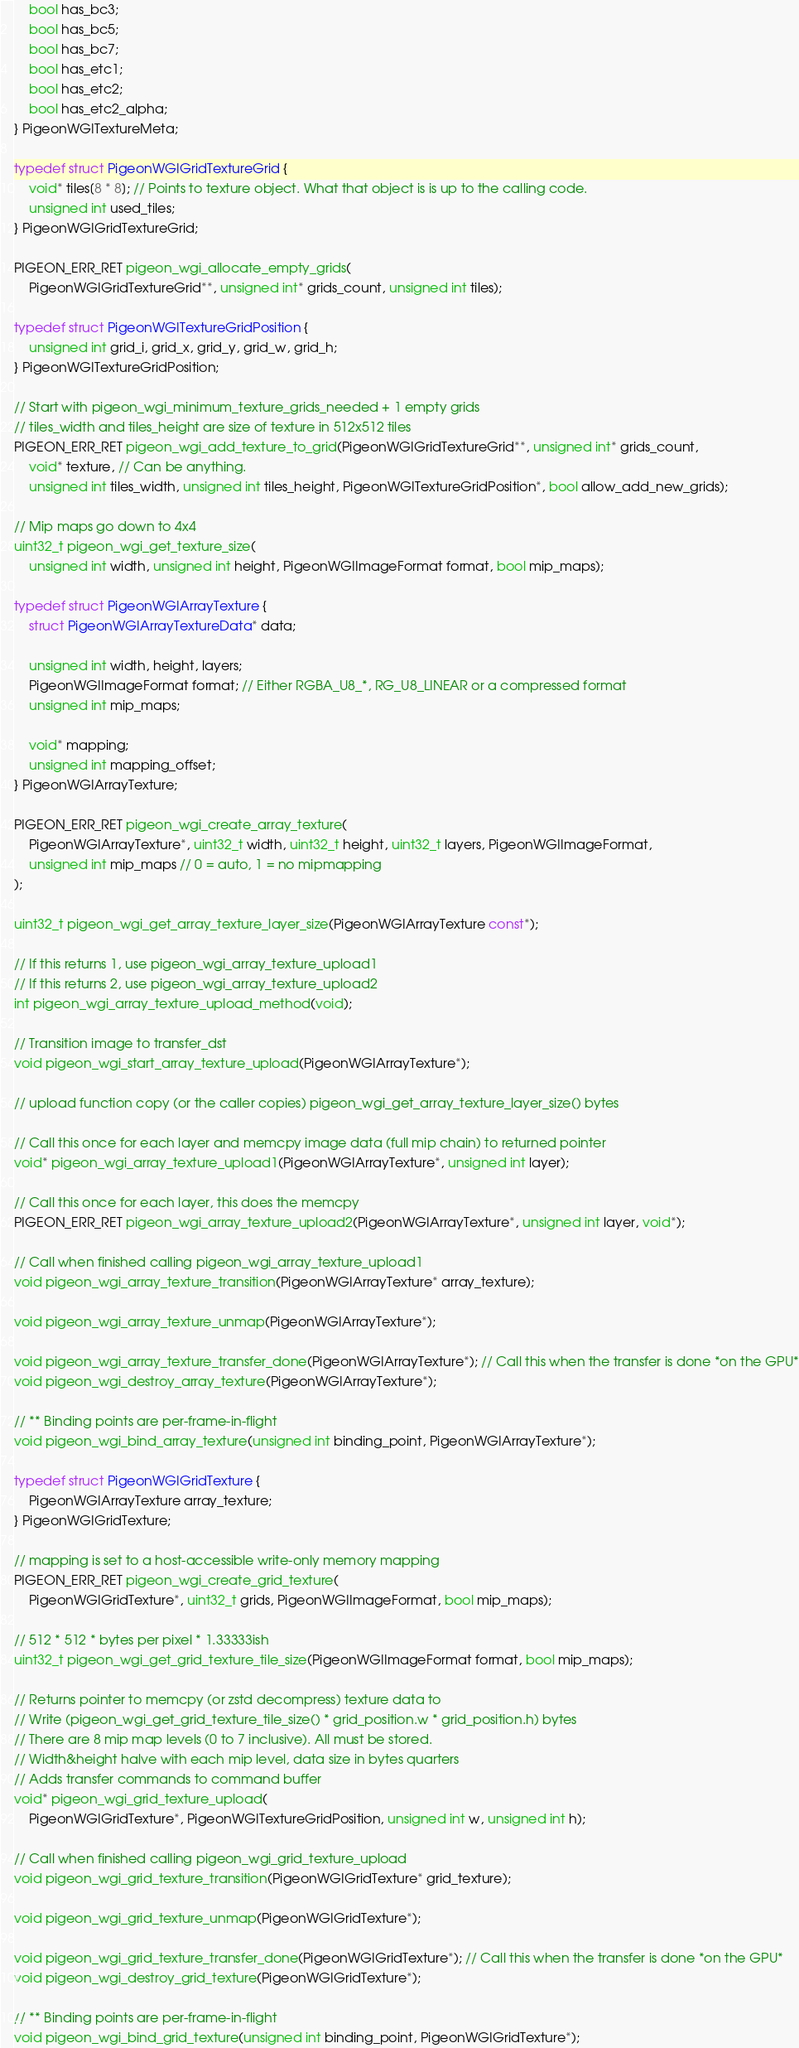<code> <loc_0><loc_0><loc_500><loc_500><_C_>	bool has_bc3;
	bool has_bc5;
	bool has_bc7;
	bool has_etc1;
	bool has_etc2;
	bool has_etc2_alpha;
} PigeonWGITextureMeta;

typedef struct PigeonWGIGridTextureGrid {
	void* tiles[8 * 8]; // Points to texture object. What that object is is up to the calling code.
	unsigned int used_tiles;
} PigeonWGIGridTextureGrid;

PIGEON_ERR_RET pigeon_wgi_allocate_empty_grids(
	PigeonWGIGridTextureGrid**, unsigned int* grids_count, unsigned int tiles);

typedef struct PigeonWGITextureGridPosition {
	unsigned int grid_i, grid_x, grid_y, grid_w, grid_h;
} PigeonWGITextureGridPosition;

// Start with pigeon_wgi_minimum_texture_grids_needed + 1 empty grids
// tiles_width and tiles_height are size of texture in 512x512 tiles
PIGEON_ERR_RET pigeon_wgi_add_texture_to_grid(PigeonWGIGridTextureGrid**, unsigned int* grids_count,
	void* texture, // Can be anything.
	unsigned int tiles_width, unsigned int tiles_height, PigeonWGITextureGridPosition*, bool allow_add_new_grids);

// Mip maps go down to 4x4
uint32_t pigeon_wgi_get_texture_size(
	unsigned int width, unsigned int height, PigeonWGIImageFormat format, bool mip_maps);

typedef struct PigeonWGIArrayTexture {
	struct PigeonWGIArrayTextureData* data;

	unsigned int width, height, layers;
	PigeonWGIImageFormat format; // Either RGBA_U8_*, RG_U8_LINEAR or a compressed format
	unsigned int mip_maps;

	void* mapping;
	unsigned int mapping_offset;
} PigeonWGIArrayTexture;

PIGEON_ERR_RET pigeon_wgi_create_array_texture(
	PigeonWGIArrayTexture*, uint32_t width, uint32_t height, uint32_t layers, PigeonWGIImageFormat,
	unsigned int mip_maps // 0 = auto, 1 = no mipmapping
);

uint32_t pigeon_wgi_get_array_texture_layer_size(PigeonWGIArrayTexture const*);

// If this returns 1, use pigeon_wgi_array_texture_upload1
// If this returns 2, use pigeon_wgi_array_texture_upload2
int pigeon_wgi_array_texture_upload_method(void);

// Transition image to transfer_dst
void pigeon_wgi_start_array_texture_upload(PigeonWGIArrayTexture*);

// upload function copy (or the caller copies) pigeon_wgi_get_array_texture_layer_size() bytes

// Call this once for each layer and memcpy image data (full mip chain) to returned pointer
void* pigeon_wgi_array_texture_upload1(PigeonWGIArrayTexture*, unsigned int layer);

// Call this once for each layer, this does the memcpy
PIGEON_ERR_RET pigeon_wgi_array_texture_upload2(PigeonWGIArrayTexture*, unsigned int layer, void*);

// Call when finished calling pigeon_wgi_array_texture_upload1
void pigeon_wgi_array_texture_transition(PigeonWGIArrayTexture* array_texture);

void pigeon_wgi_array_texture_unmap(PigeonWGIArrayTexture*);

void pigeon_wgi_array_texture_transfer_done(PigeonWGIArrayTexture*); // Call this when the transfer is done *on the GPU*
void pigeon_wgi_destroy_array_texture(PigeonWGIArrayTexture*);

// ** Binding points are per-frame-in-flight
void pigeon_wgi_bind_array_texture(unsigned int binding_point, PigeonWGIArrayTexture*);

typedef struct PigeonWGIGridTexture {
	PigeonWGIArrayTexture array_texture;
} PigeonWGIGridTexture;

// mapping is set to a host-accessible write-only memory mapping
PIGEON_ERR_RET pigeon_wgi_create_grid_texture(
	PigeonWGIGridTexture*, uint32_t grids, PigeonWGIImageFormat, bool mip_maps);

// 512 * 512 * bytes per pixel * 1.33333ish
uint32_t pigeon_wgi_get_grid_texture_tile_size(PigeonWGIImageFormat format, bool mip_maps);

// Returns pointer to memcpy (or zstd decompress) texture data to
// Write (pigeon_wgi_get_grid_texture_tile_size() * grid_position.w * grid_position.h) bytes
// There are 8 mip map levels (0 to 7 inclusive). All must be stored.
// Width&height halve with each mip level, data size in bytes quarters
// Adds transfer commands to command buffer
void* pigeon_wgi_grid_texture_upload(
	PigeonWGIGridTexture*, PigeonWGITextureGridPosition, unsigned int w, unsigned int h);

// Call when finished calling pigeon_wgi_grid_texture_upload
void pigeon_wgi_grid_texture_transition(PigeonWGIGridTexture* grid_texture);

void pigeon_wgi_grid_texture_unmap(PigeonWGIGridTexture*);

void pigeon_wgi_grid_texture_transfer_done(PigeonWGIGridTexture*); // Call this when the transfer is done *on the GPU*
void pigeon_wgi_destroy_grid_texture(PigeonWGIGridTexture*);

// ** Binding points are per-frame-in-flight
void pigeon_wgi_bind_grid_texture(unsigned int binding_point, PigeonWGIGridTexture*);
</code> 